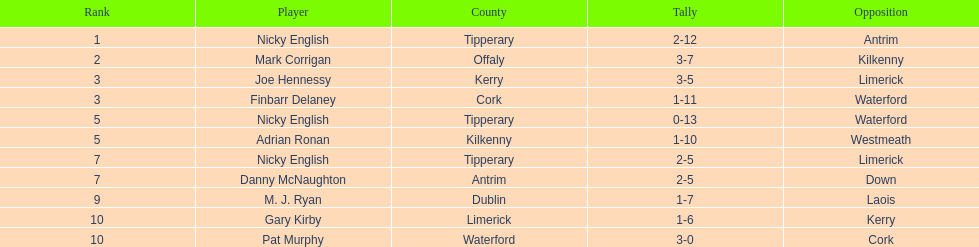If you added all the total's up, what would the number be? 138. 